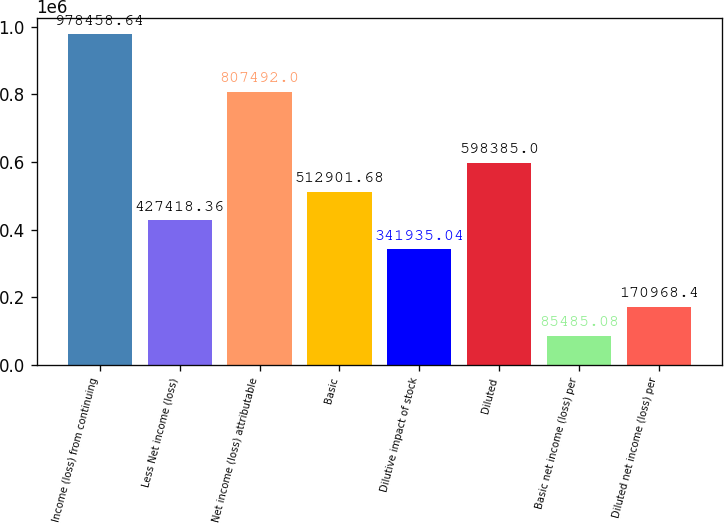Convert chart to OTSL. <chart><loc_0><loc_0><loc_500><loc_500><bar_chart><fcel>Income (loss) from continuing<fcel>Less Net income (loss)<fcel>Net income (loss) attributable<fcel>Basic<fcel>Dilutive impact of stock<fcel>Diluted<fcel>Basic net income (loss) per<fcel>Diluted net income (loss) per<nl><fcel>978459<fcel>427418<fcel>807492<fcel>512902<fcel>341935<fcel>598385<fcel>85485.1<fcel>170968<nl></chart> 